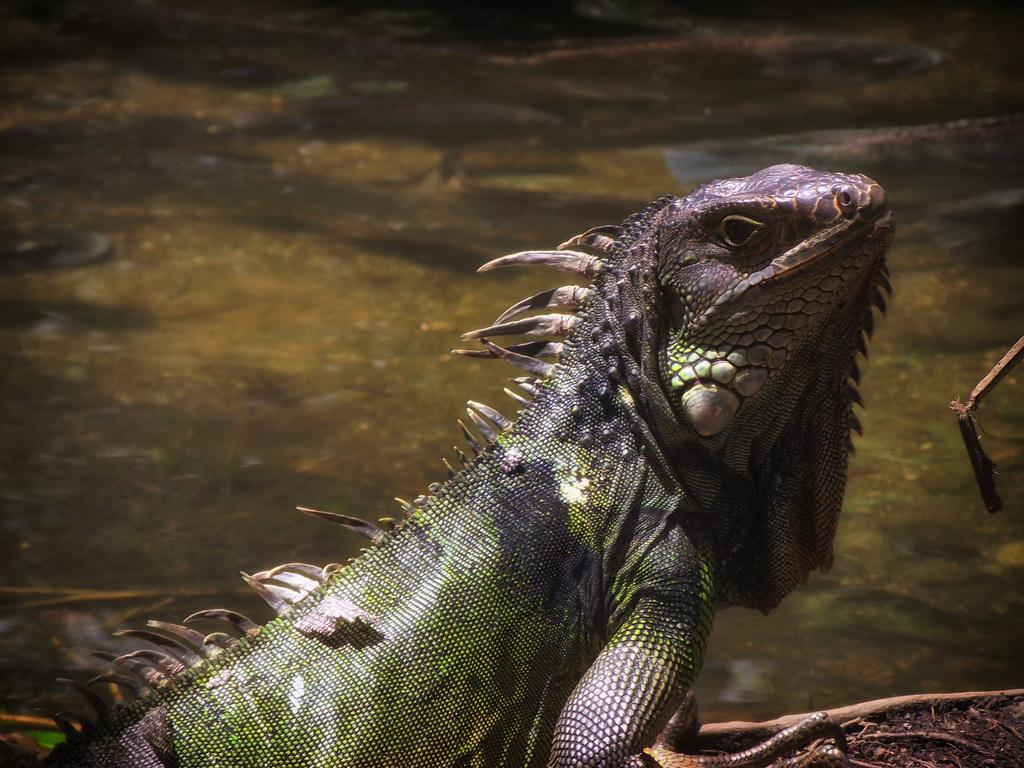What type of animal is in the image? There is a reptile in the image. Where is the reptile located in the image? The reptile is on the ground. What else can be seen in the image besides the reptile? There is water visible in the image. What type of orange is the chicken holding in the image? There is no chicken or orange present in the image; it features a reptile on the ground with water visible. 